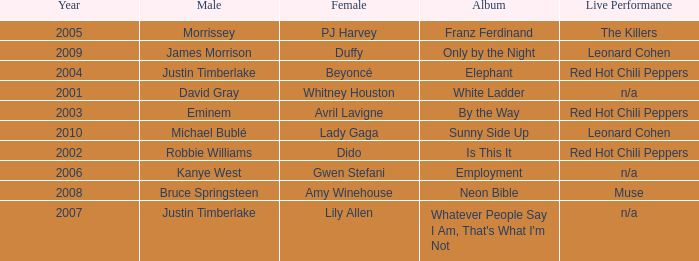Which male is paired with dido in 2004? Robbie Williams. 